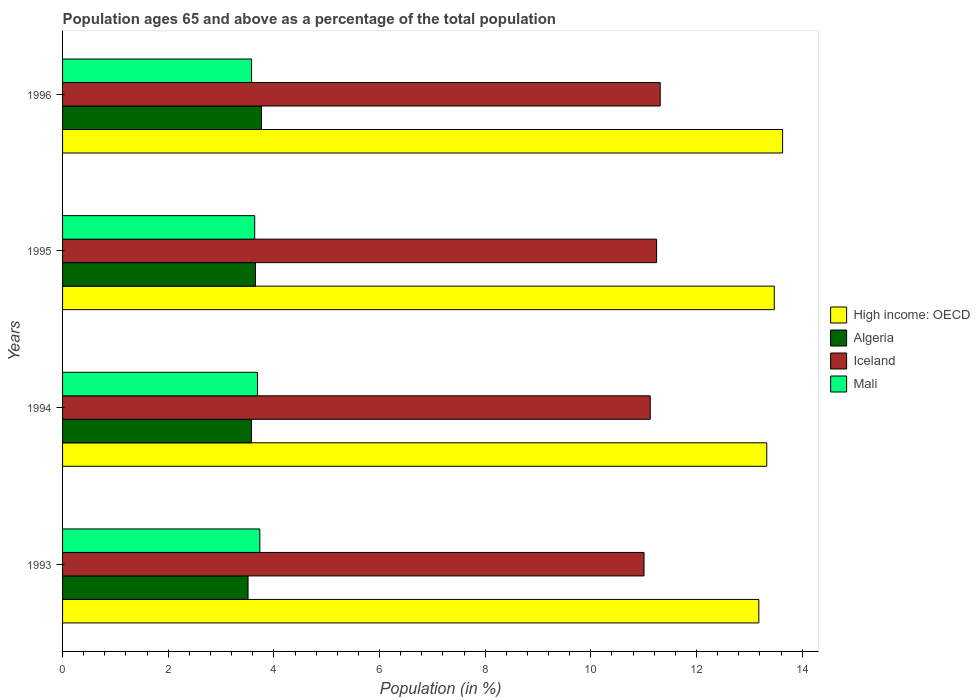Are the number of bars per tick equal to the number of legend labels?
Make the answer very short. Yes. How many bars are there on the 4th tick from the bottom?
Your response must be concise. 4. In how many cases, is the number of bars for a given year not equal to the number of legend labels?
Offer a very short reply. 0. What is the percentage of the population ages 65 and above in Algeria in 1996?
Your answer should be compact. 3.77. Across all years, what is the maximum percentage of the population ages 65 and above in Iceland?
Provide a short and direct response. 11.31. Across all years, what is the minimum percentage of the population ages 65 and above in High income: OECD?
Keep it short and to the point. 13.18. In which year was the percentage of the population ages 65 and above in Iceland minimum?
Offer a very short reply. 1993. What is the total percentage of the population ages 65 and above in Mali in the graph?
Make the answer very short. 14.64. What is the difference between the percentage of the population ages 65 and above in High income: OECD in 1993 and that in 1995?
Provide a short and direct response. -0.29. What is the difference between the percentage of the population ages 65 and above in Mali in 1994 and the percentage of the population ages 65 and above in Iceland in 1993?
Offer a very short reply. -7.32. What is the average percentage of the population ages 65 and above in Mali per year?
Offer a terse response. 3.66. In the year 1993, what is the difference between the percentage of the population ages 65 and above in Iceland and percentage of the population ages 65 and above in High income: OECD?
Offer a terse response. -2.17. What is the ratio of the percentage of the population ages 65 and above in Mali in 1993 to that in 1996?
Your answer should be very brief. 1.04. Is the percentage of the population ages 65 and above in Algeria in 1993 less than that in 1994?
Provide a succinct answer. Yes. What is the difference between the highest and the second highest percentage of the population ages 65 and above in Iceland?
Provide a succinct answer. 0.07. What is the difference between the highest and the lowest percentage of the population ages 65 and above in High income: OECD?
Your response must be concise. 0.45. Is the sum of the percentage of the population ages 65 and above in Iceland in 1993 and 1994 greater than the maximum percentage of the population ages 65 and above in Algeria across all years?
Ensure brevity in your answer.  Yes. Is it the case that in every year, the sum of the percentage of the population ages 65 and above in High income: OECD and percentage of the population ages 65 and above in Algeria is greater than the sum of percentage of the population ages 65 and above in Iceland and percentage of the population ages 65 and above in Mali?
Offer a very short reply. No. What does the 1st bar from the top in 1995 represents?
Give a very brief answer. Mali. Is it the case that in every year, the sum of the percentage of the population ages 65 and above in Mali and percentage of the population ages 65 and above in Iceland is greater than the percentage of the population ages 65 and above in Algeria?
Provide a short and direct response. Yes. Are all the bars in the graph horizontal?
Offer a terse response. Yes. Are the values on the major ticks of X-axis written in scientific E-notation?
Your answer should be compact. No. Does the graph contain any zero values?
Your answer should be very brief. No. Does the graph contain grids?
Make the answer very short. No. Where does the legend appear in the graph?
Make the answer very short. Center right. How are the legend labels stacked?
Your answer should be compact. Vertical. What is the title of the graph?
Your answer should be very brief. Population ages 65 and above as a percentage of the total population. What is the label or title of the Y-axis?
Your answer should be very brief. Years. What is the Population (in %) of High income: OECD in 1993?
Ensure brevity in your answer.  13.18. What is the Population (in %) in Algeria in 1993?
Your answer should be very brief. 3.51. What is the Population (in %) of Iceland in 1993?
Provide a short and direct response. 11.01. What is the Population (in %) in Mali in 1993?
Your answer should be very brief. 3.73. What is the Population (in %) in High income: OECD in 1994?
Keep it short and to the point. 13.33. What is the Population (in %) of Algeria in 1994?
Provide a short and direct response. 3.58. What is the Population (in %) in Iceland in 1994?
Ensure brevity in your answer.  11.12. What is the Population (in %) in Mali in 1994?
Provide a succinct answer. 3.69. What is the Population (in %) of High income: OECD in 1995?
Make the answer very short. 13.47. What is the Population (in %) in Algeria in 1995?
Keep it short and to the point. 3.65. What is the Population (in %) in Iceland in 1995?
Offer a terse response. 11.25. What is the Population (in %) in Mali in 1995?
Your response must be concise. 3.64. What is the Population (in %) in High income: OECD in 1996?
Offer a very short reply. 13.63. What is the Population (in %) in Algeria in 1996?
Your answer should be very brief. 3.77. What is the Population (in %) of Iceland in 1996?
Keep it short and to the point. 11.31. What is the Population (in %) in Mali in 1996?
Your response must be concise. 3.58. Across all years, what is the maximum Population (in %) of High income: OECD?
Your answer should be compact. 13.63. Across all years, what is the maximum Population (in %) in Algeria?
Provide a succinct answer. 3.77. Across all years, what is the maximum Population (in %) of Iceland?
Offer a very short reply. 11.31. Across all years, what is the maximum Population (in %) in Mali?
Your response must be concise. 3.73. Across all years, what is the minimum Population (in %) of High income: OECD?
Provide a succinct answer. 13.18. Across all years, what is the minimum Population (in %) in Algeria?
Give a very brief answer. 3.51. Across all years, what is the minimum Population (in %) in Iceland?
Give a very brief answer. 11.01. Across all years, what is the minimum Population (in %) of Mali?
Make the answer very short. 3.58. What is the total Population (in %) of High income: OECD in the graph?
Your response must be concise. 53.61. What is the total Population (in %) of Algeria in the graph?
Provide a short and direct response. 14.5. What is the total Population (in %) in Iceland in the graph?
Give a very brief answer. 44.69. What is the total Population (in %) of Mali in the graph?
Make the answer very short. 14.64. What is the difference between the Population (in %) of Algeria in 1993 and that in 1994?
Provide a succinct answer. -0.06. What is the difference between the Population (in %) of Iceland in 1993 and that in 1994?
Ensure brevity in your answer.  -0.12. What is the difference between the Population (in %) of Mali in 1993 and that in 1994?
Keep it short and to the point. 0.04. What is the difference between the Population (in %) in High income: OECD in 1993 and that in 1995?
Offer a very short reply. -0.29. What is the difference between the Population (in %) in Algeria in 1993 and that in 1995?
Your answer should be compact. -0.14. What is the difference between the Population (in %) in Iceland in 1993 and that in 1995?
Your answer should be compact. -0.24. What is the difference between the Population (in %) of Mali in 1993 and that in 1995?
Give a very brief answer. 0.1. What is the difference between the Population (in %) of High income: OECD in 1993 and that in 1996?
Make the answer very short. -0.45. What is the difference between the Population (in %) in Algeria in 1993 and that in 1996?
Offer a very short reply. -0.25. What is the difference between the Population (in %) in Iceland in 1993 and that in 1996?
Offer a terse response. -0.31. What is the difference between the Population (in %) of Mali in 1993 and that in 1996?
Your answer should be compact. 0.16. What is the difference between the Population (in %) of High income: OECD in 1994 and that in 1995?
Your answer should be very brief. -0.14. What is the difference between the Population (in %) of Algeria in 1994 and that in 1995?
Keep it short and to the point. -0.08. What is the difference between the Population (in %) of Iceland in 1994 and that in 1995?
Provide a short and direct response. -0.12. What is the difference between the Population (in %) in Mali in 1994 and that in 1995?
Ensure brevity in your answer.  0.05. What is the difference between the Population (in %) of High income: OECD in 1994 and that in 1996?
Make the answer very short. -0.3. What is the difference between the Population (in %) of Algeria in 1994 and that in 1996?
Make the answer very short. -0.19. What is the difference between the Population (in %) of Iceland in 1994 and that in 1996?
Offer a very short reply. -0.19. What is the difference between the Population (in %) of Mali in 1994 and that in 1996?
Your answer should be very brief. 0.11. What is the difference between the Population (in %) in High income: OECD in 1995 and that in 1996?
Offer a very short reply. -0.16. What is the difference between the Population (in %) in Algeria in 1995 and that in 1996?
Your response must be concise. -0.11. What is the difference between the Population (in %) of Iceland in 1995 and that in 1996?
Ensure brevity in your answer.  -0.07. What is the difference between the Population (in %) in Mali in 1995 and that in 1996?
Provide a succinct answer. 0.06. What is the difference between the Population (in %) in High income: OECD in 1993 and the Population (in %) in Algeria in 1994?
Provide a short and direct response. 9.6. What is the difference between the Population (in %) in High income: OECD in 1993 and the Population (in %) in Iceland in 1994?
Give a very brief answer. 2.06. What is the difference between the Population (in %) in High income: OECD in 1993 and the Population (in %) in Mali in 1994?
Your response must be concise. 9.49. What is the difference between the Population (in %) in Algeria in 1993 and the Population (in %) in Iceland in 1994?
Your answer should be compact. -7.61. What is the difference between the Population (in %) of Algeria in 1993 and the Population (in %) of Mali in 1994?
Offer a very short reply. -0.18. What is the difference between the Population (in %) in Iceland in 1993 and the Population (in %) in Mali in 1994?
Provide a short and direct response. 7.32. What is the difference between the Population (in %) of High income: OECD in 1993 and the Population (in %) of Algeria in 1995?
Keep it short and to the point. 9.53. What is the difference between the Population (in %) in High income: OECD in 1993 and the Population (in %) in Iceland in 1995?
Offer a terse response. 1.93. What is the difference between the Population (in %) in High income: OECD in 1993 and the Population (in %) in Mali in 1995?
Provide a succinct answer. 9.54. What is the difference between the Population (in %) of Algeria in 1993 and the Population (in %) of Iceland in 1995?
Offer a very short reply. -7.73. What is the difference between the Population (in %) in Algeria in 1993 and the Population (in %) in Mali in 1995?
Provide a short and direct response. -0.13. What is the difference between the Population (in %) of Iceland in 1993 and the Population (in %) of Mali in 1995?
Offer a very short reply. 7.37. What is the difference between the Population (in %) of High income: OECD in 1993 and the Population (in %) of Algeria in 1996?
Your answer should be compact. 9.42. What is the difference between the Population (in %) of High income: OECD in 1993 and the Population (in %) of Iceland in 1996?
Offer a terse response. 1.87. What is the difference between the Population (in %) of High income: OECD in 1993 and the Population (in %) of Mali in 1996?
Provide a succinct answer. 9.6. What is the difference between the Population (in %) in Algeria in 1993 and the Population (in %) in Iceland in 1996?
Ensure brevity in your answer.  -7.8. What is the difference between the Population (in %) of Algeria in 1993 and the Population (in %) of Mali in 1996?
Your answer should be compact. -0.07. What is the difference between the Population (in %) in Iceland in 1993 and the Population (in %) in Mali in 1996?
Your response must be concise. 7.43. What is the difference between the Population (in %) of High income: OECD in 1994 and the Population (in %) of Algeria in 1995?
Keep it short and to the point. 9.68. What is the difference between the Population (in %) in High income: OECD in 1994 and the Population (in %) in Iceland in 1995?
Your answer should be compact. 2.08. What is the difference between the Population (in %) in High income: OECD in 1994 and the Population (in %) in Mali in 1995?
Give a very brief answer. 9.69. What is the difference between the Population (in %) in Algeria in 1994 and the Population (in %) in Iceland in 1995?
Keep it short and to the point. -7.67. What is the difference between the Population (in %) in Algeria in 1994 and the Population (in %) in Mali in 1995?
Offer a terse response. -0.06. What is the difference between the Population (in %) in Iceland in 1994 and the Population (in %) in Mali in 1995?
Keep it short and to the point. 7.49. What is the difference between the Population (in %) in High income: OECD in 1994 and the Population (in %) in Algeria in 1996?
Provide a short and direct response. 9.57. What is the difference between the Population (in %) in High income: OECD in 1994 and the Population (in %) in Iceland in 1996?
Your response must be concise. 2.02. What is the difference between the Population (in %) in High income: OECD in 1994 and the Population (in %) in Mali in 1996?
Your response must be concise. 9.75. What is the difference between the Population (in %) of Algeria in 1994 and the Population (in %) of Iceland in 1996?
Offer a terse response. -7.74. What is the difference between the Population (in %) of Algeria in 1994 and the Population (in %) of Mali in 1996?
Ensure brevity in your answer.  -0. What is the difference between the Population (in %) of Iceland in 1994 and the Population (in %) of Mali in 1996?
Keep it short and to the point. 7.55. What is the difference between the Population (in %) in High income: OECD in 1995 and the Population (in %) in Algeria in 1996?
Keep it short and to the point. 9.71. What is the difference between the Population (in %) of High income: OECD in 1995 and the Population (in %) of Iceland in 1996?
Offer a terse response. 2.16. What is the difference between the Population (in %) of High income: OECD in 1995 and the Population (in %) of Mali in 1996?
Your answer should be very brief. 9.89. What is the difference between the Population (in %) in Algeria in 1995 and the Population (in %) in Iceland in 1996?
Offer a terse response. -7.66. What is the difference between the Population (in %) of Algeria in 1995 and the Population (in %) of Mali in 1996?
Ensure brevity in your answer.  0.07. What is the difference between the Population (in %) of Iceland in 1995 and the Population (in %) of Mali in 1996?
Your answer should be very brief. 7.67. What is the average Population (in %) in High income: OECD per year?
Your response must be concise. 13.4. What is the average Population (in %) of Algeria per year?
Provide a succinct answer. 3.63. What is the average Population (in %) of Iceland per year?
Give a very brief answer. 11.17. What is the average Population (in %) of Mali per year?
Make the answer very short. 3.66. In the year 1993, what is the difference between the Population (in %) of High income: OECD and Population (in %) of Algeria?
Offer a terse response. 9.67. In the year 1993, what is the difference between the Population (in %) of High income: OECD and Population (in %) of Iceland?
Your answer should be compact. 2.17. In the year 1993, what is the difference between the Population (in %) in High income: OECD and Population (in %) in Mali?
Offer a very short reply. 9.45. In the year 1993, what is the difference between the Population (in %) of Algeria and Population (in %) of Iceland?
Give a very brief answer. -7.5. In the year 1993, what is the difference between the Population (in %) of Algeria and Population (in %) of Mali?
Your answer should be very brief. -0.22. In the year 1993, what is the difference between the Population (in %) of Iceland and Population (in %) of Mali?
Ensure brevity in your answer.  7.27. In the year 1994, what is the difference between the Population (in %) in High income: OECD and Population (in %) in Algeria?
Give a very brief answer. 9.75. In the year 1994, what is the difference between the Population (in %) in High income: OECD and Population (in %) in Iceland?
Your response must be concise. 2.21. In the year 1994, what is the difference between the Population (in %) of High income: OECD and Population (in %) of Mali?
Keep it short and to the point. 9.64. In the year 1994, what is the difference between the Population (in %) in Algeria and Population (in %) in Iceland?
Ensure brevity in your answer.  -7.55. In the year 1994, what is the difference between the Population (in %) of Algeria and Population (in %) of Mali?
Offer a very short reply. -0.11. In the year 1994, what is the difference between the Population (in %) in Iceland and Population (in %) in Mali?
Provide a short and direct response. 7.44. In the year 1995, what is the difference between the Population (in %) in High income: OECD and Population (in %) in Algeria?
Give a very brief answer. 9.82. In the year 1995, what is the difference between the Population (in %) of High income: OECD and Population (in %) of Iceland?
Provide a succinct answer. 2.23. In the year 1995, what is the difference between the Population (in %) of High income: OECD and Population (in %) of Mali?
Give a very brief answer. 9.84. In the year 1995, what is the difference between the Population (in %) of Algeria and Population (in %) of Iceland?
Provide a short and direct response. -7.59. In the year 1995, what is the difference between the Population (in %) in Algeria and Population (in %) in Mali?
Provide a short and direct response. 0.01. In the year 1995, what is the difference between the Population (in %) of Iceland and Population (in %) of Mali?
Provide a short and direct response. 7.61. In the year 1996, what is the difference between the Population (in %) of High income: OECD and Population (in %) of Algeria?
Your answer should be compact. 9.87. In the year 1996, what is the difference between the Population (in %) of High income: OECD and Population (in %) of Iceland?
Ensure brevity in your answer.  2.32. In the year 1996, what is the difference between the Population (in %) of High income: OECD and Population (in %) of Mali?
Offer a very short reply. 10.05. In the year 1996, what is the difference between the Population (in %) in Algeria and Population (in %) in Iceland?
Offer a terse response. -7.55. In the year 1996, what is the difference between the Population (in %) in Algeria and Population (in %) in Mali?
Your answer should be compact. 0.19. In the year 1996, what is the difference between the Population (in %) of Iceland and Population (in %) of Mali?
Provide a succinct answer. 7.74. What is the ratio of the Population (in %) of High income: OECD in 1993 to that in 1994?
Your answer should be compact. 0.99. What is the ratio of the Population (in %) of Algeria in 1993 to that in 1994?
Offer a very short reply. 0.98. What is the ratio of the Population (in %) of Iceland in 1993 to that in 1994?
Your answer should be very brief. 0.99. What is the ratio of the Population (in %) in High income: OECD in 1993 to that in 1995?
Keep it short and to the point. 0.98. What is the ratio of the Population (in %) in Algeria in 1993 to that in 1995?
Your answer should be compact. 0.96. What is the ratio of the Population (in %) in Iceland in 1993 to that in 1995?
Ensure brevity in your answer.  0.98. What is the ratio of the Population (in %) in Mali in 1993 to that in 1995?
Keep it short and to the point. 1.03. What is the ratio of the Population (in %) of High income: OECD in 1993 to that in 1996?
Give a very brief answer. 0.97. What is the ratio of the Population (in %) in Algeria in 1993 to that in 1996?
Make the answer very short. 0.93. What is the ratio of the Population (in %) in Iceland in 1993 to that in 1996?
Your answer should be compact. 0.97. What is the ratio of the Population (in %) in Mali in 1993 to that in 1996?
Provide a short and direct response. 1.04. What is the ratio of the Population (in %) in High income: OECD in 1994 to that in 1995?
Provide a short and direct response. 0.99. What is the ratio of the Population (in %) in Algeria in 1994 to that in 1995?
Ensure brevity in your answer.  0.98. What is the ratio of the Population (in %) of Iceland in 1994 to that in 1995?
Provide a short and direct response. 0.99. What is the ratio of the Population (in %) of Mali in 1994 to that in 1995?
Make the answer very short. 1.01. What is the ratio of the Population (in %) of Algeria in 1994 to that in 1996?
Your answer should be very brief. 0.95. What is the ratio of the Population (in %) in Iceland in 1994 to that in 1996?
Keep it short and to the point. 0.98. What is the ratio of the Population (in %) in Mali in 1994 to that in 1996?
Provide a succinct answer. 1.03. What is the ratio of the Population (in %) of High income: OECD in 1995 to that in 1996?
Your response must be concise. 0.99. What is the ratio of the Population (in %) in Mali in 1995 to that in 1996?
Ensure brevity in your answer.  1.02. What is the difference between the highest and the second highest Population (in %) in High income: OECD?
Ensure brevity in your answer.  0.16. What is the difference between the highest and the second highest Population (in %) of Algeria?
Provide a succinct answer. 0.11. What is the difference between the highest and the second highest Population (in %) in Iceland?
Your answer should be compact. 0.07. What is the difference between the highest and the second highest Population (in %) in Mali?
Offer a very short reply. 0.04. What is the difference between the highest and the lowest Population (in %) of High income: OECD?
Offer a very short reply. 0.45. What is the difference between the highest and the lowest Population (in %) of Algeria?
Your answer should be compact. 0.25. What is the difference between the highest and the lowest Population (in %) in Iceland?
Offer a terse response. 0.31. What is the difference between the highest and the lowest Population (in %) in Mali?
Ensure brevity in your answer.  0.16. 